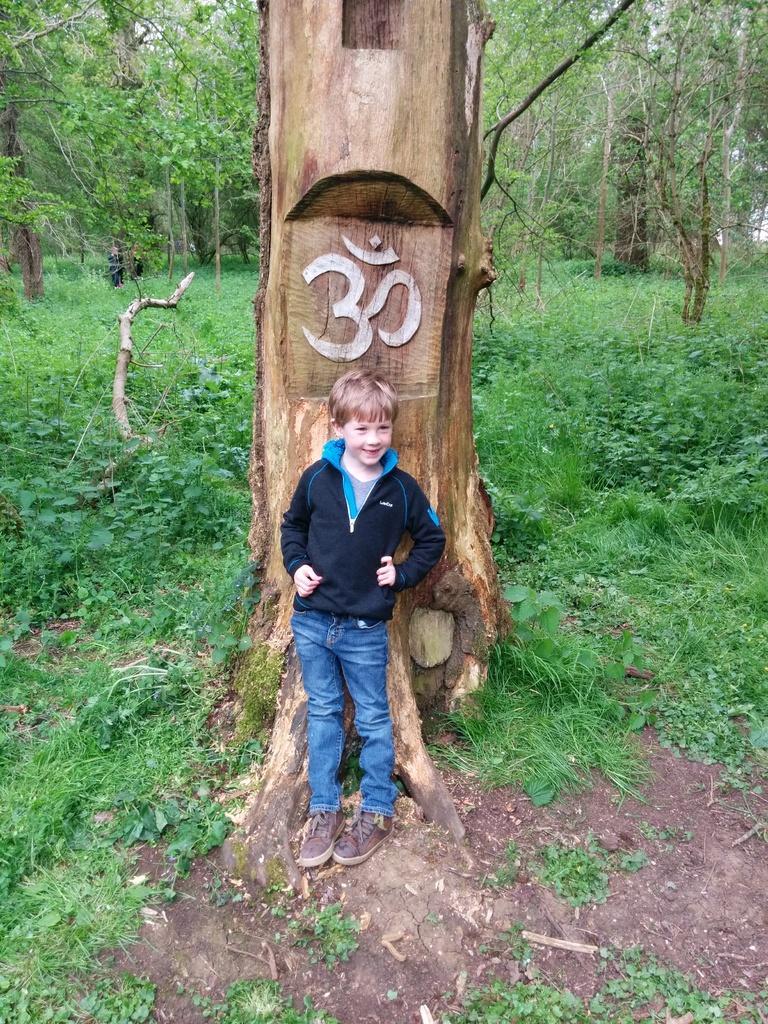In one or two sentences, can you explain what this image depicts? In this picture we can see a boy standing on the ground and smiling, grass and a symbol on a tree trunk and in the background we can see some people and trees. 